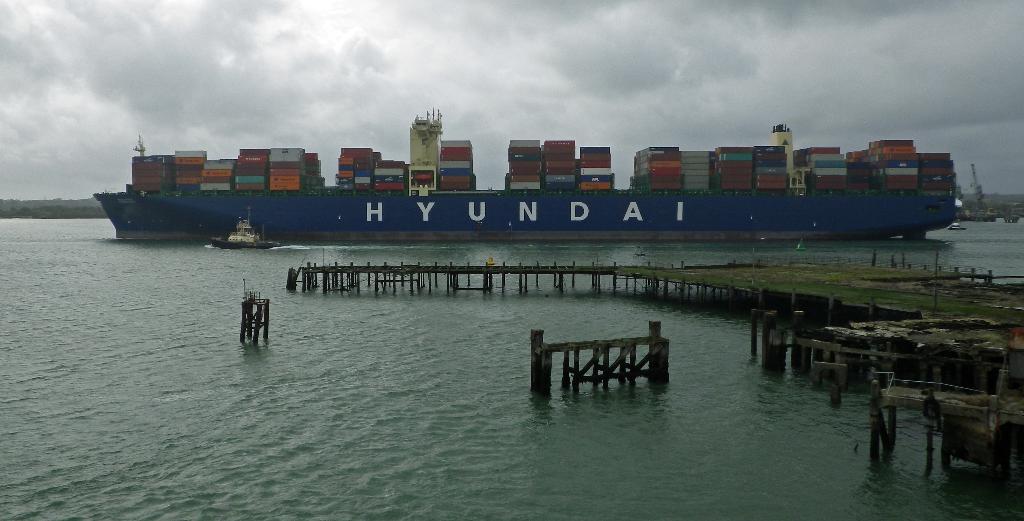Please provide a concise description of this image. In this picture we can see fences, platform, boat, ship on water and in the background we can see some objects, sky with clouds. 